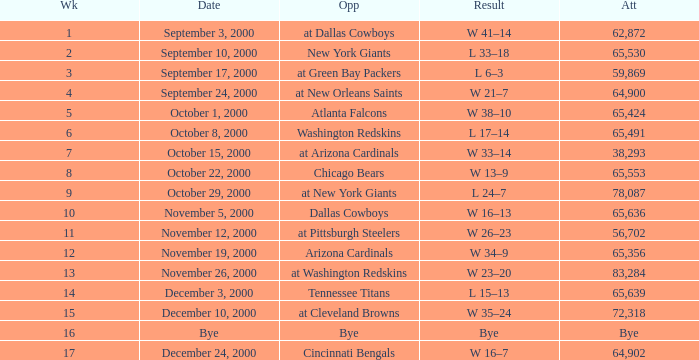What was the attendance when the Cincinnati Bengals were the opponents? 64902.0. 